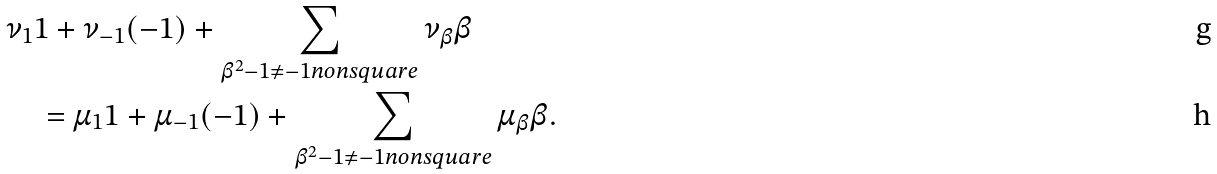<formula> <loc_0><loc_0><loc_500><loc_500>& \nu _ { 1 } 1 + \nu _ { - 1 } ( - 1 ) + \sum _ { \beta ^ { 2 } - 1 \neq - 1 n o n s q u a r e } \nu _ { \beta } \beta \\ & \quad = \mu _ { 1 } 1 + \mu _ { - 1 } ( - 1 ) + \sum _ { \beta ^ { 2 } - 1 \neq - 1 n o n s q u a r e } \mu _ { \beta } \beta .</formula> 